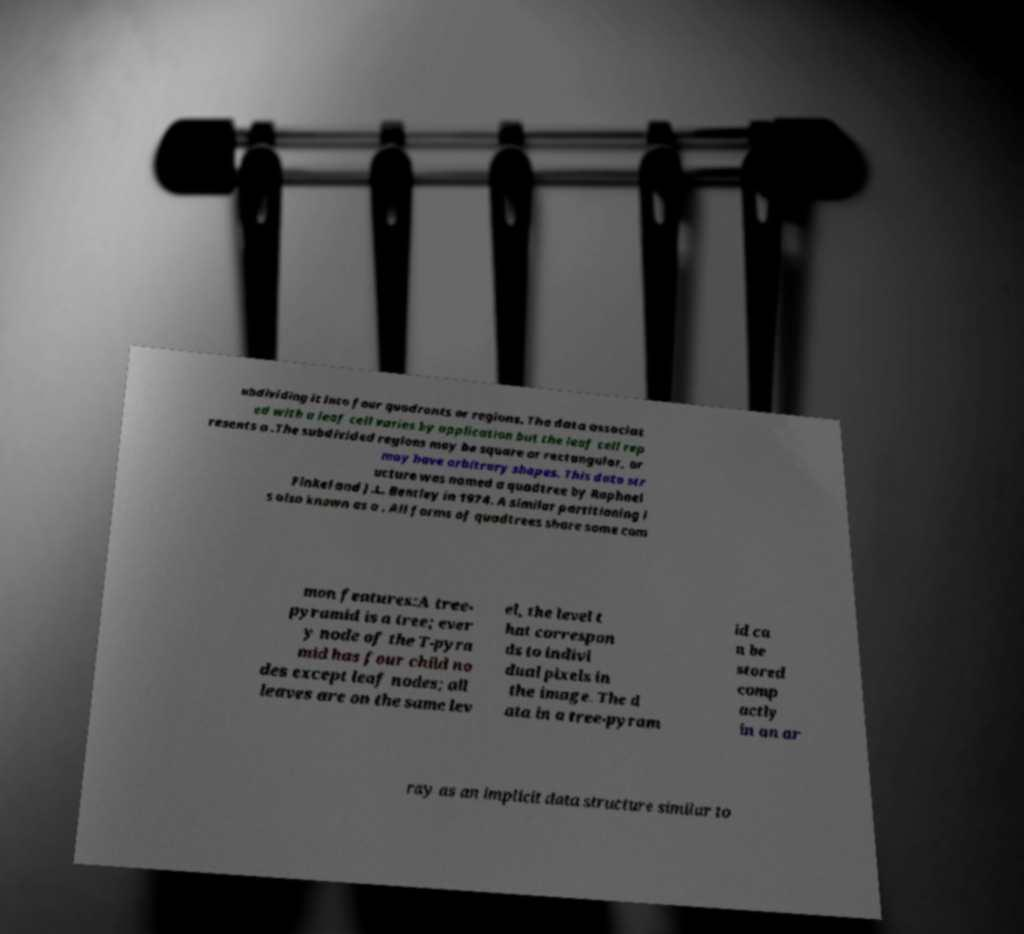What messages or text are displayed in this image? I need them in a readable, typed format. ubdividing it into four quadrants or regions. The data associat ed with a leaf cell varies by application but the leaf cell rep resents a .The subdivided regions may be square or rectangular, or may have arbitrary shapes. This data str ucture was named a quadtree by Raphael Finkel and J.L. Bentley in 1974. A similar partitioning i s also known as a . All forms of quadtrees share some com mon features:A tree- pyramid is a tree; ever y node of the T-pyra mid has four child no des except leaf nodes; all leaves are on the same lev el, the level t hat correspon ds to indivi dual pixels in the image. The d ata in a tree-pyram id ca n be stored comp actly in an ar ray as an implicit data structure similar to 